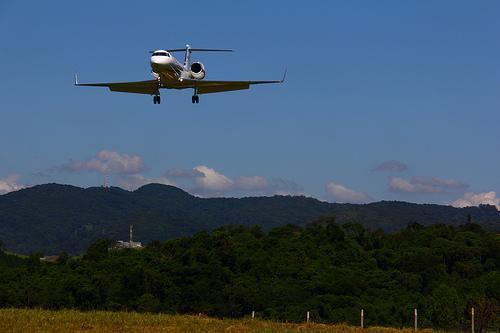How many planes are in the sky?
Give a very brief answer. 1. 